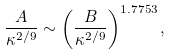Convert formula to latex. <formula><loc_0><loc_0><loc_500><loc_500>\frac { A } { \kappa ^ { 2 / 9 } } \sim \left ( \frac { B } { \kappa ^ { 2 / 9 } } \right ) ^ { 1 . 7 7 5 3 } ,</formula> 